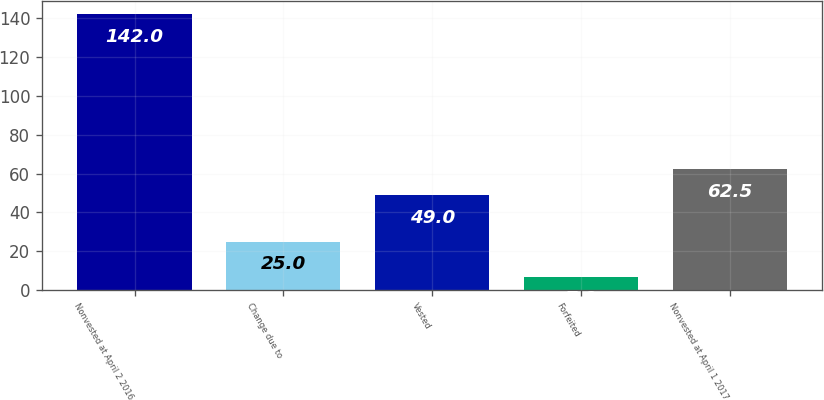Convert chart. <chart><loc_0><loc_0><loc_500><loc_500><bar_chart><fcel>Nonvested at April 2 2016<fcel>Change due to<fcel>Vested<fcel>Forfeited<fcel>Nonvested at April 1 2017<nl><fcel>142<fcel>25<fcel>49<fcel>7<fcel>62.5<nl></chart> 